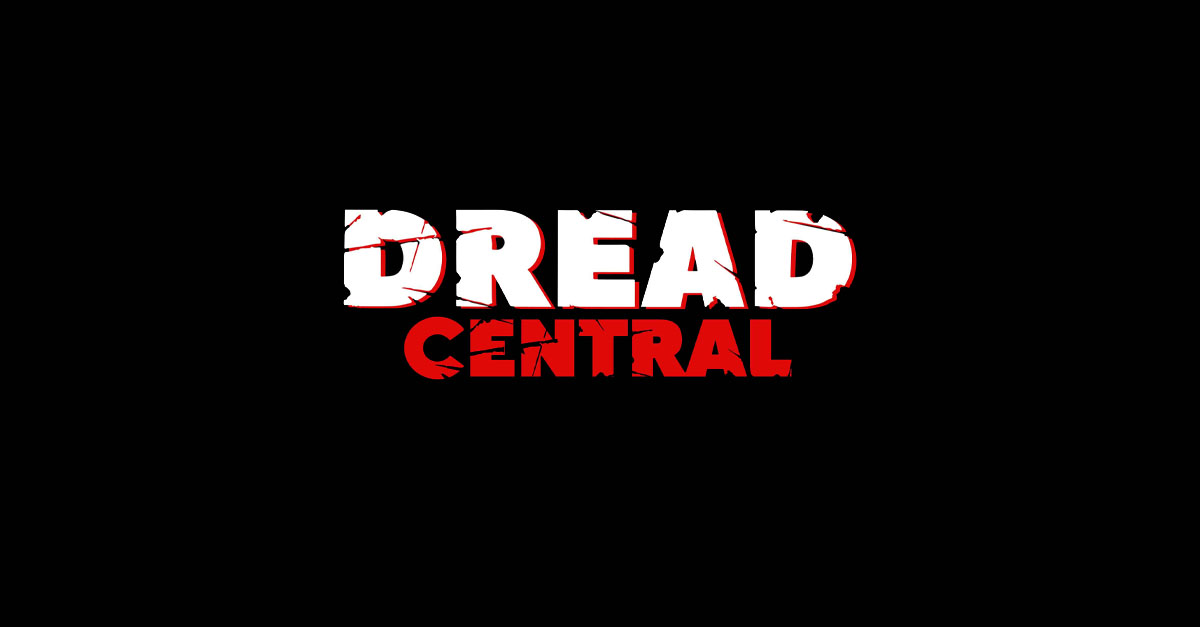What emotions could the creator of this graphic be trying to evoke in an audience through the word 'DREAD'? The use of 'DREAD' in this context is a direct appeal to evoke feelings of anxiety, fear, and the sense of an ominous threat. It taps into the primal instincts of the viewer, arousing a sense of unease and anticipation for something horrifying or disturbing that might be lurking in the shadows. This word choice is deliberate in targeting the emotional core of the audience, priming them for a psychologically intense experience.  Could there be any other interpretations of the imagery used that might not be strictly related to horror? While the dominant theme of the design points towards horror, the stylized rupture of the text could also suggest themes of chaos, disruption, or a break from the norm. It could be construed that the imagery is a metaphoric representation of challenging societal norms, portraying a world where the regular order is fragmented, which could resonate with genres like dystopian fiction, or narratives exploring psychological turmoil and the breakdown of reality. 